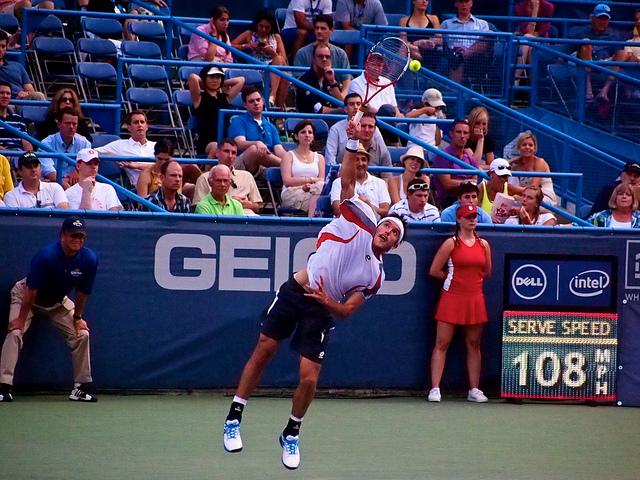What is the speed of the serve?
Write a very short answer. 108 mph. What company has the biggest ad?
Give a very brief answer. Geico. Are both of his feet in the air?
Write a very short answer. Yes. 